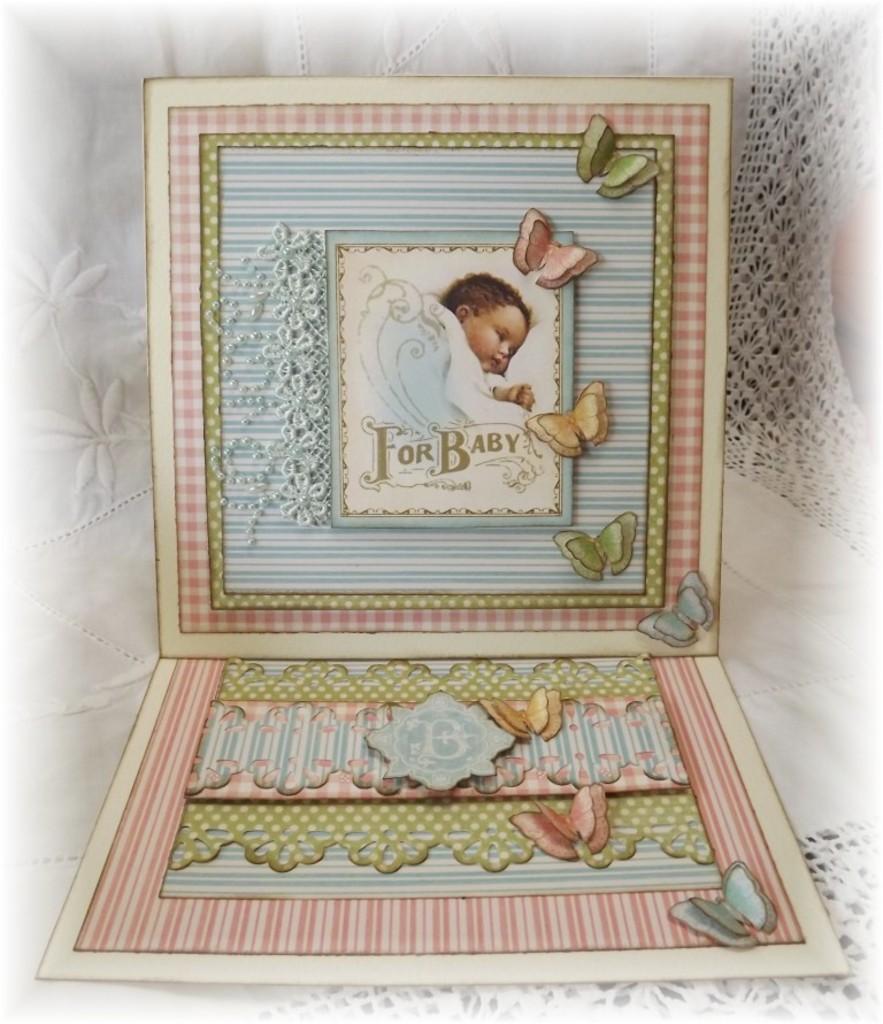Who is this picture frame meant to be used for?
Offer a very short reply. Baby. 